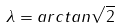<formula> <loc_0><loc_0><loc_500><loc_500>\lambda = a r c t a n \sqrt { 2 }</formula> 